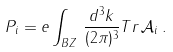Convert formula to latex. <formula><loc_0><loc_0><loc_500><loc_500>P _ { i } = e \int _ { B Z } \, \frac { d ^ { 3 } k } { ( 2 \pi ) ^ { 3 } } T r \, \mathcal { A } _ { i } \, .</formula> 